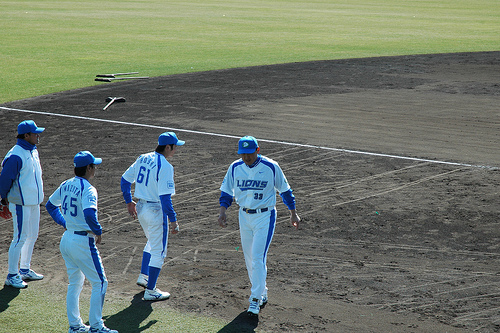<image>
Can you confirm if the baseball field is to the right of the man? No. The baseball field is not to the right of the man. The horizontal positioning shows a different relationship. 